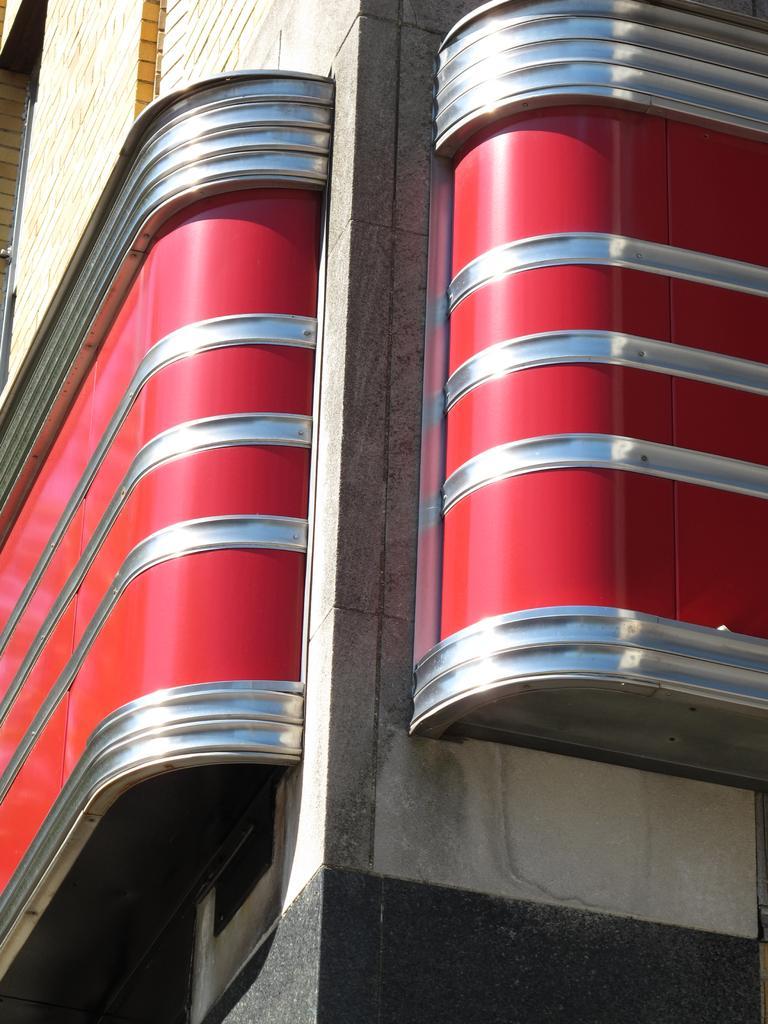Can you describe this image briefly? In the picture I can see the building construction and there is an architecture design on the wall of the building. 